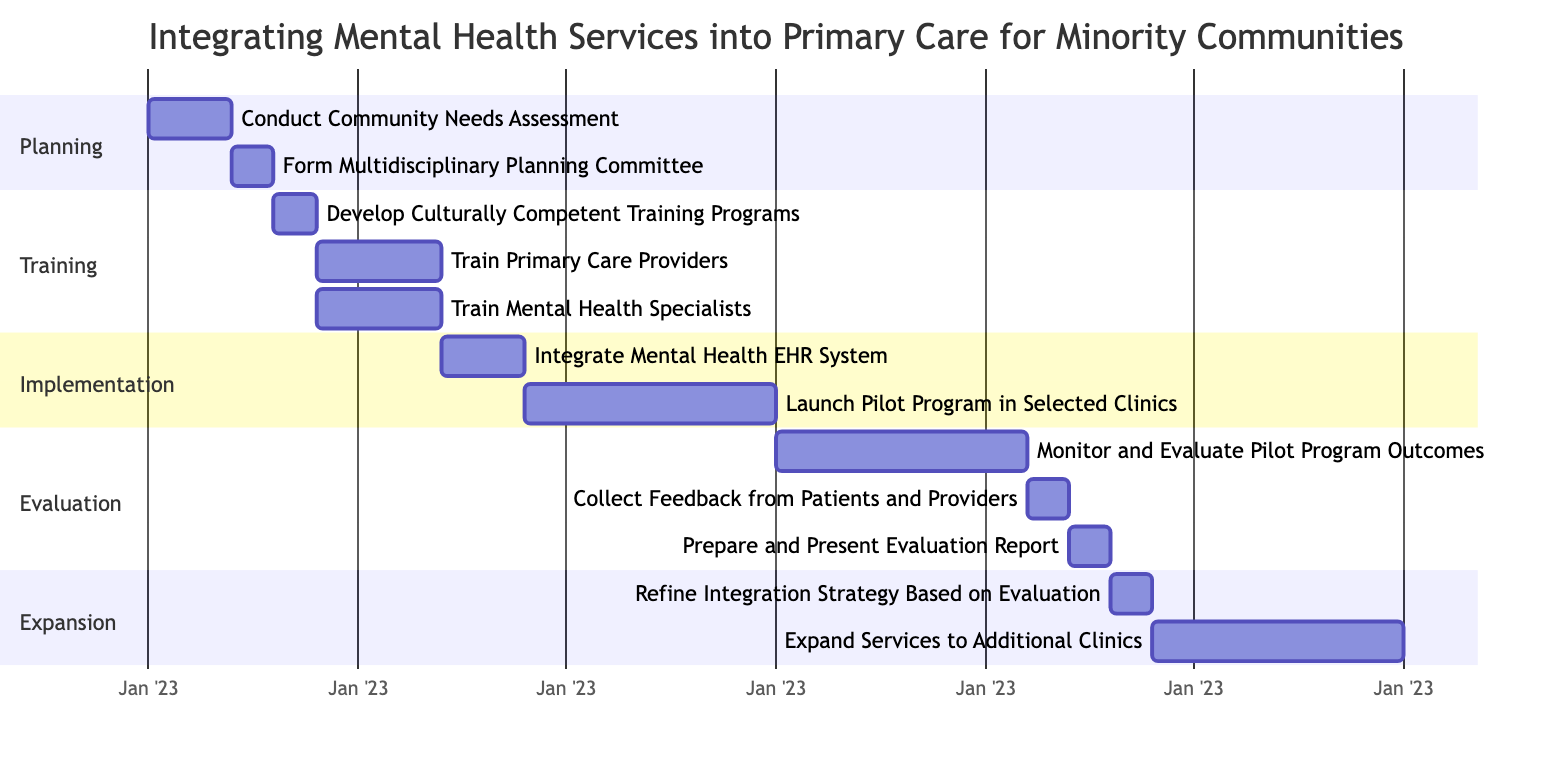What is the duration of the "Conduct Community Needs Assessment" task? The task "Conduct Community Needs Assessment" is listed in the "Planning" section of the Gantt Chart. Its duration is explicitly stated as "2 months."
Answer: 2 months How many tasks are in the "Training" phase? The "Training" phase contains three tasks: "Develop Culturally Competent Training Programs," "Train Primary Care Providers," and "Train Mental Health Specialists." Therefore, the total number of tasks is three.
Answer: 3 What is the dependency for launching the pilot program? According to the Gantt Chart, "Launch Pilot Program in Selected Clinics" depends on the successful completion of "Integrate Mental Health EHR System," which is shown as a direct prerequisite.
Answer: Integrate Mental Health EHR System Which phase includes the task "Prepare and Present Evaluation Report"? The task "Prepare and Present Evaluation Report" is placed in the "Evaluation" phase. This can be confirmed by locating it within the section labeled "Evaluation."
Answer: Evaluation What follows the "Monitor and Evaluate Pilot Program Outcomes"? Based on the Gantt Chart, the task "Collect Feedback from Patients and Providers" immediately follows "Monitor and Evaluate Pilot Program Outcomes," as indicated by the dependencies and timeline.
Answer: Collect Feedback from Patients and Providers How long does the "Expand Services to Additional Clinics" task take? The task "Expand Services to Additional Clinics" has a specified duration of "6 months" shown in the "Expansion" section of the Gantt Chart.
Answer: 6 months What is the minimum time frame from planning to the evaluation report? The time frame can be calculated by adding the durations of each consecutive task that leads to the "Prepare and Present Evaluation Report," starting from "Conduct Community Needs Assessment" to the evaluation report, totaling 19 months.
Answer: 19 months How many months does the total implementation phase last? The "Implementation" phase consists of two tasks: "Integrate Mental Health EHR System" for 2 months and "Launch Pilot Program in Selected Clinics" for 6 months. Therefore, the total time for the implementation phase is 8 months.
Answer: 8 months 